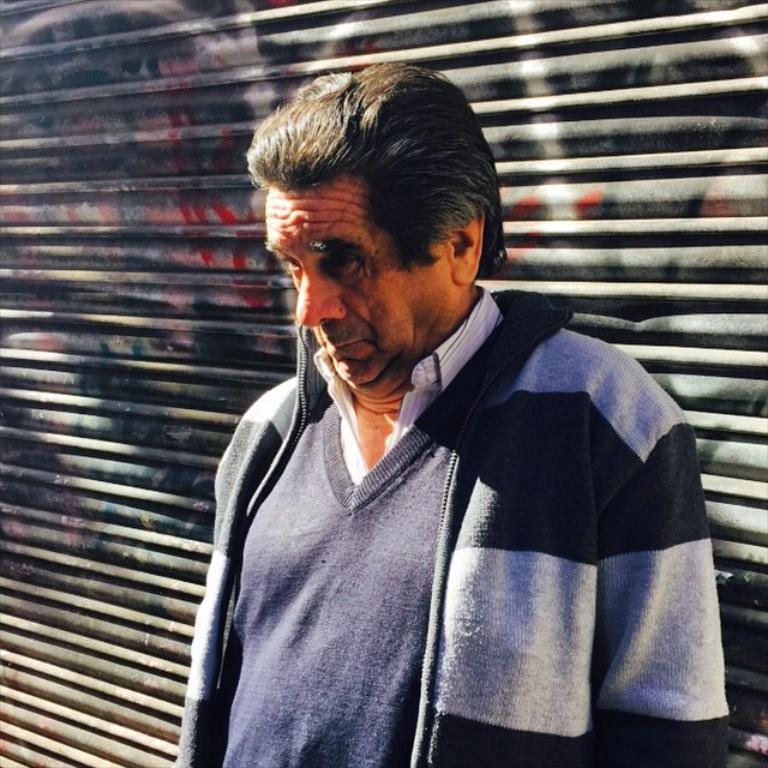What is the main subject of the image? There is a man standing in the image. Can you describe the background of the image? There is a shutter in the background of the image. How many geese are visible in the image? There are no geese present in the image. What type of memory is being used by the man in the image? The image does not provide information about the man's memory, so it cannot be determined from the image. 